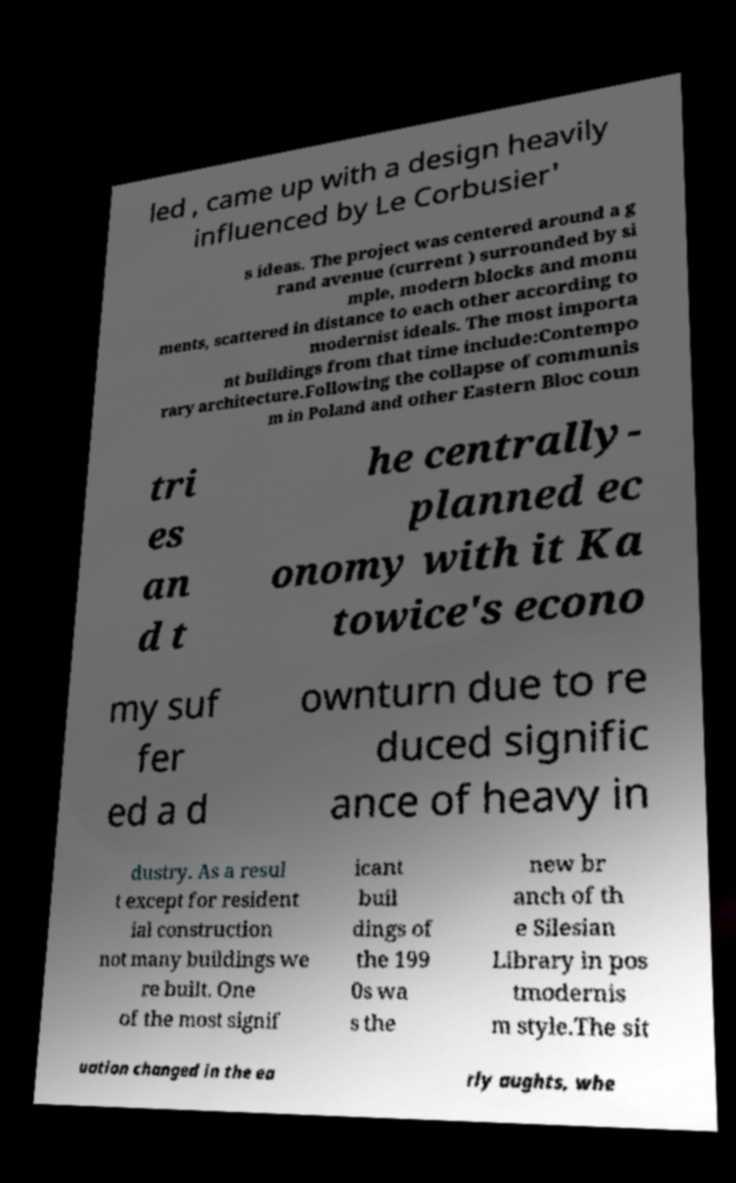I need the written content from this picture converted into text. Can you do that? led , came up with a design heavily influenced by Le Corbusier' s ideas. The project was centered around a g rand avenue (current ) surrounded by si mple, modern blocks and monu ments, scattered in distance to each other according to modernist ideals. The most importa nt buildings from that time include:Contempo rary architecture.Following the collapse of communis m in Poland and other Eastern Bloc coun tri es an d t he centrally- planned ec onomy with it Ka towice's econo my suf fer ed a d ownturn due to re duced signific ance of heavy in dustry. As a resul t except for resident ial construction not many buildings we re built. One of the most signif icant buil dings of the 199 0s wa s the new br anch of th e Silesian Library in pos tmodernis m style.The sit uation changed in the ea rly aughts, whe 